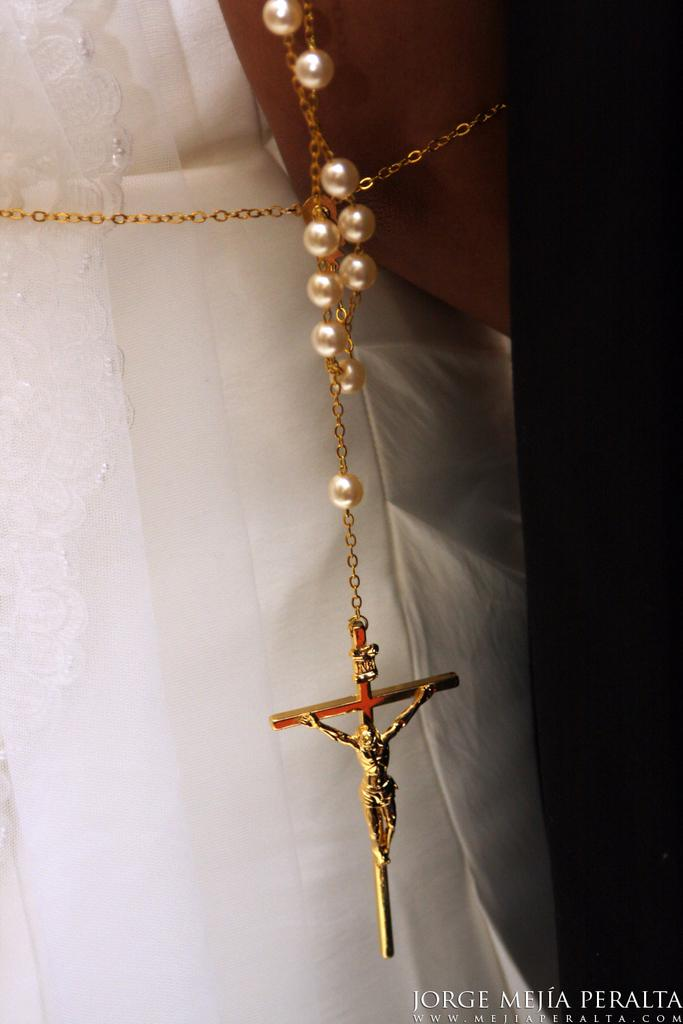Who or what is present in the image? There is a person in the image. What is the person wearing? The person is wearing a white dress. Are there any accessories visible in the image? Yes, there is a gold-colored chain visible in the image. What type of bird is perched on the person's shoulder in the image? There is no bird present in the image; the person is wearing a white dress and has a gold-colored chain visible. 